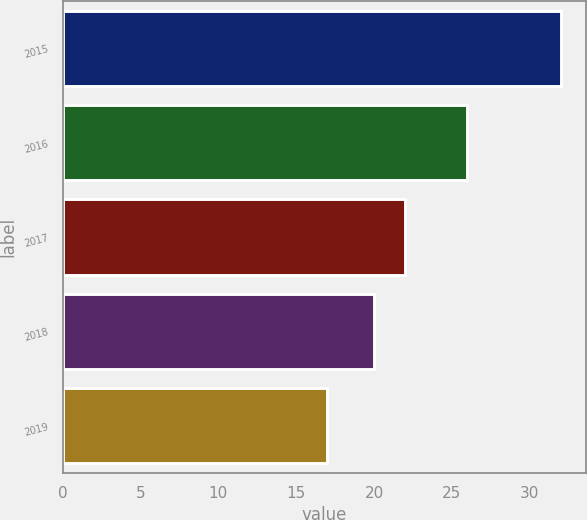Convert chart to OTSL. <chart><loc_0><loc_0><loc_500><loc_500><bar_chart><fcel>2015<fcel>2016<fcel>2017<fcel>2018<fcel>2019<nl><fcel>32<fcel>26<fcel>22<fcel>20<fcel>17<nl></chart> 